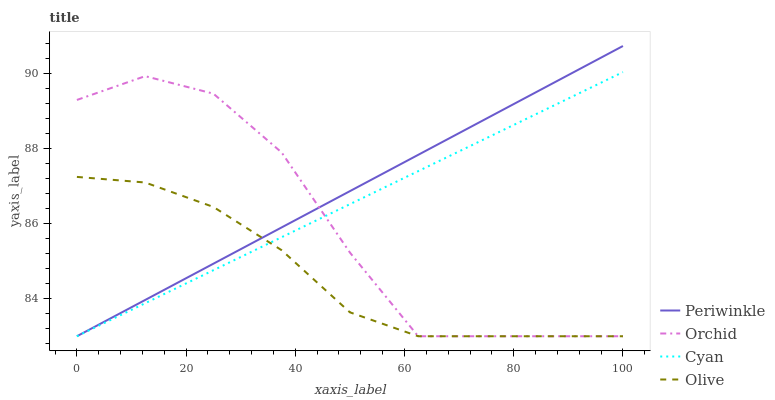Does Olive have the minimum area under the curve?
Answer yes or no. Yes. Does Periwinkle have the maximum area under the curve?
Answer yes or no. Yes. Does Cyan have the minimum area under the curve?
Answer yes or no. No. Does Cyan have the maximum area under the curve?
Answer yes or no. No. Is Periwinkle the smoothest?
Answer yes or no. Yes. Is Orchid the roughest?
Answer yes or no. Yes. Is Cyan the smoothest?
Answer yes or no. No. Is Cyan the roughest?
Answer yes or no. No. Does Cyan have the highest value?
Answer yes or no. No. 